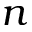Convert formula to latex. <formula><loc_0><loc_0><loc_500><loc_500>n</formula> 